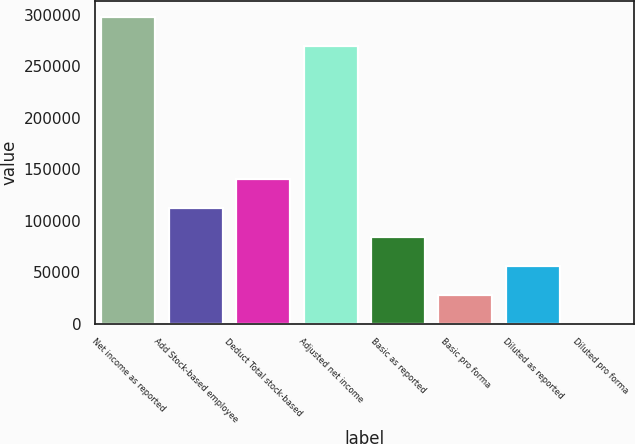<chart> <loc_0><loc_0><loc_500><loc_500><bar_chart><fcel>Net income as reported<fcel>Add Stock-based employee<fcel>Deduct Total stock-based<fcel>Adjusted net income<fcel>Basic as reported<fcel>Basic pro forma<fcel>Diluted as reported<fcel>Diluted pro forma<nl><fcel>297948<fcel>112006<fcel>140007<fcel>269947<fcel>84004.8<fcel>28002.7<fcel>56003.7<fcel>1.66<nl></chart> 